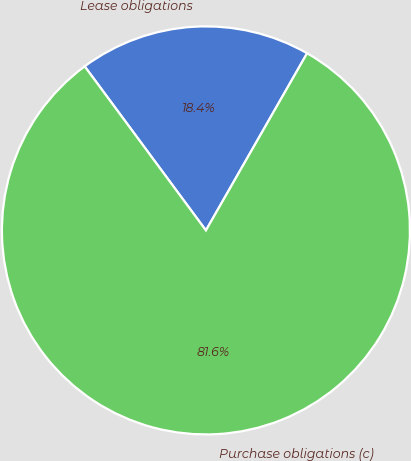Convert chart to OTSL. <chart><loc_0><loc_0><loc_500><loc_500><pie_chart><fcel>Lease obligations<fcel>Purchase obligations (c)<nl><fcel>18.39%<fcel>81.61%<nl></chart> 